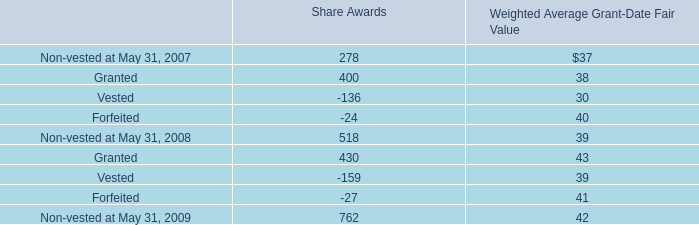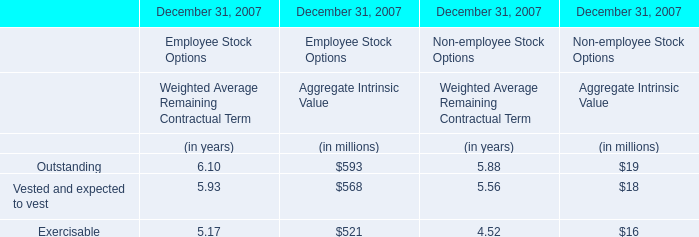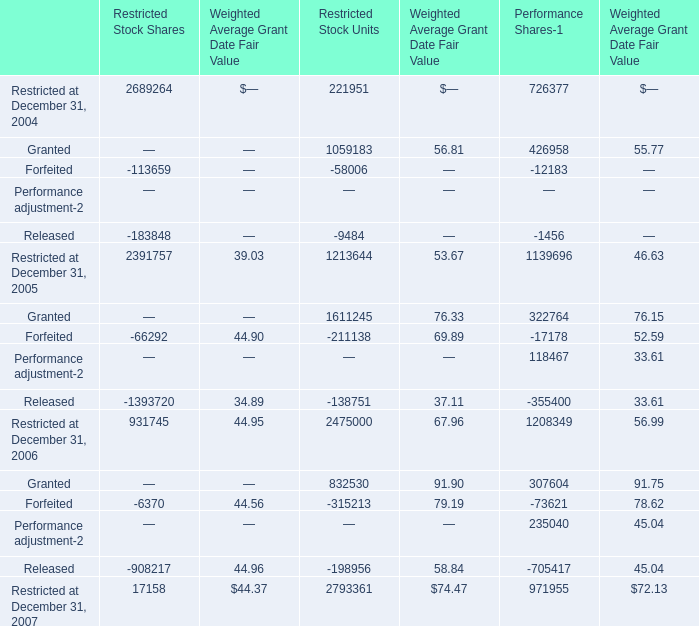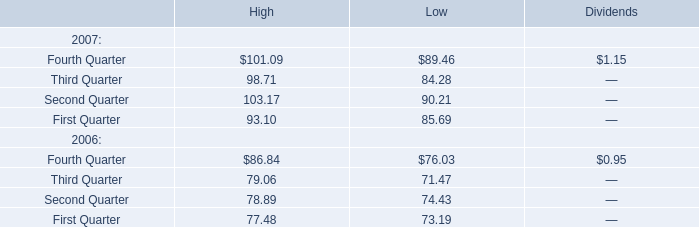What is the sum of the Vested and expected to vest in the sections where Outstanding of Aggregate Intrinsic Value is positive? (in million) 
Computations: (568 + 18)
Answer: 586.0. 